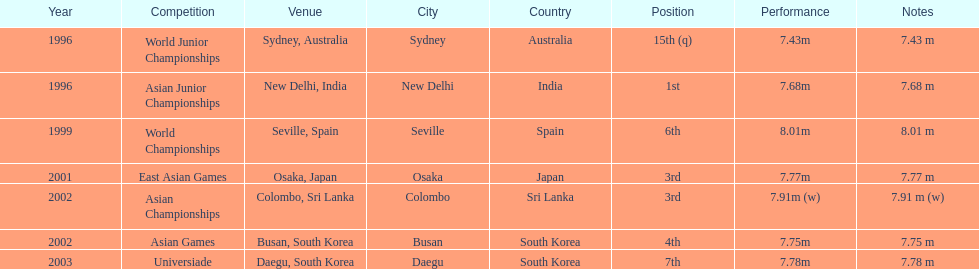Which year was his best jump? 1999. 